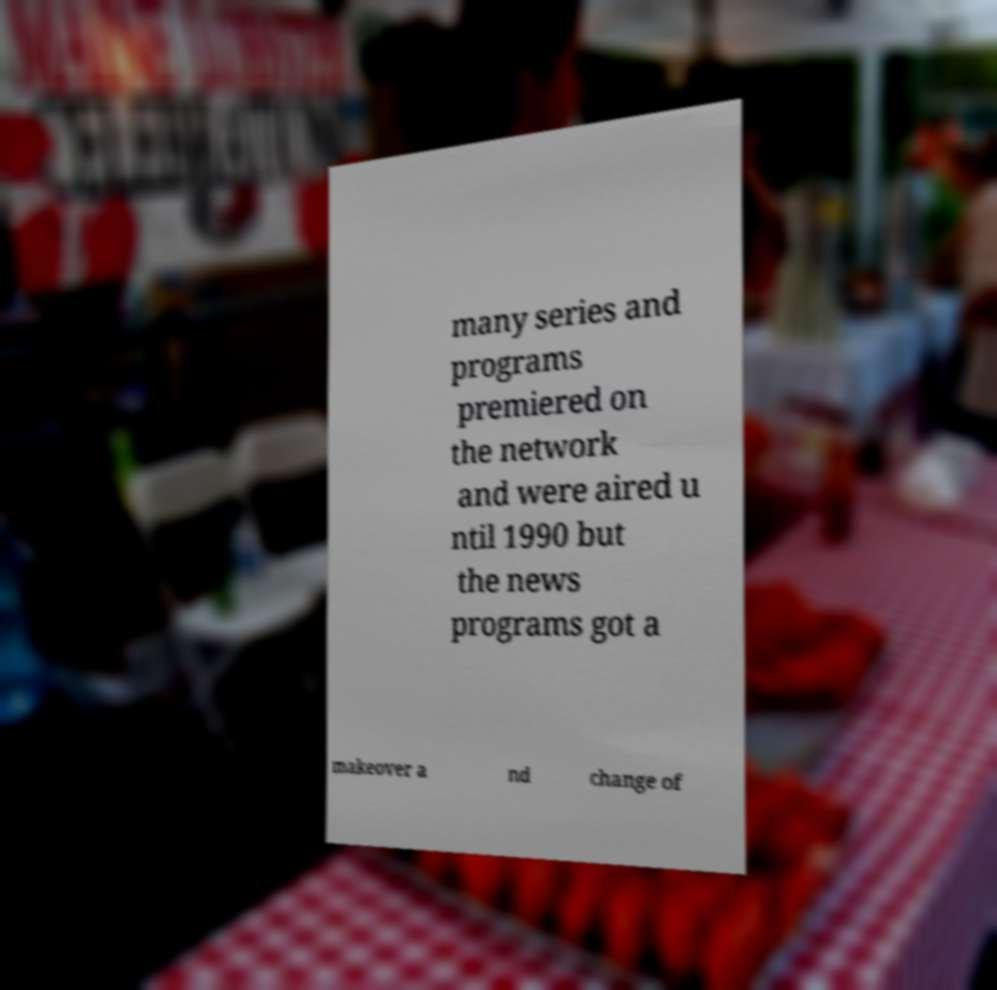I need the written content from this picture converted into text. Can you do that? many series and programs premiered on the network and were aired u ntil 1990 but the news programs got a makeover a nd change of 